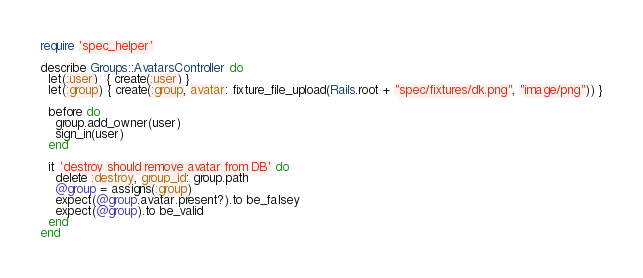<code> <loc_0><loc_0><loc_500><loc_500><_Ruby_>require 'spec_helper'

describe Groups::AvatarsController do
  let(:user)  { create(:user) }
  let(:group) { create(:group, avatar: fixture_file_upload(Rails.root + "spec/fixtures/dk.png", "image/png")) }

  before do
    group.add_owner(user)
    sign_in(user)
  end

  it 'destroy should remove avatar from DB' do
    delete :destroy, group_id: group.path
    @group = assigns(:group)
    expect(@group.avatar.present?).to be_falsey
    expect(@group).to be_valid
  end
end
</code> 